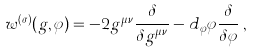<formula> <loc_0><loc_0><loc_500><loc_500>w ^ { ( \sigma ) } ( g , \varphi ) = - 2 g ^ { \mu \nu } \frac { \delta } { \delta g ^ { \mu \nu } } - d _ { \varphi } \varphi { \frac { \delta } { \delta \varphi } } \, ,</formula> 